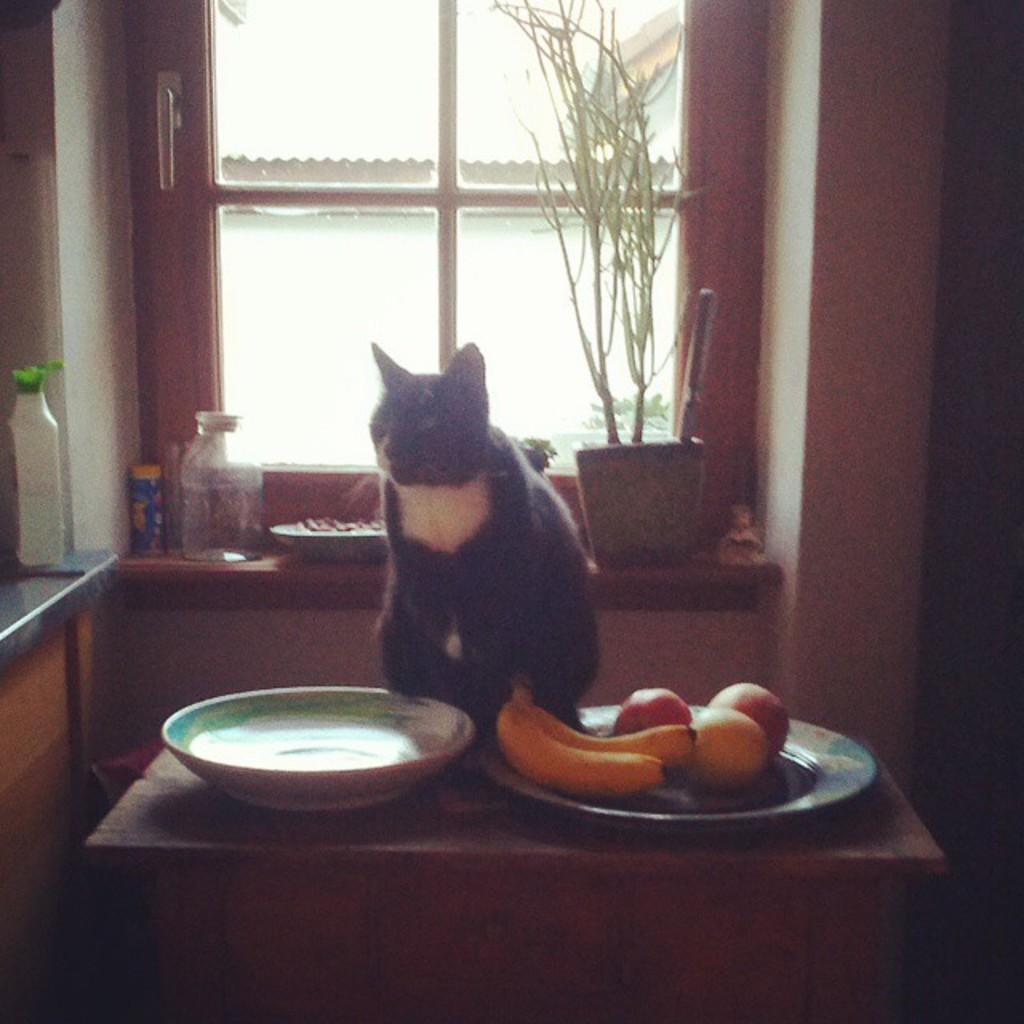Please provide a concise description of this image. There is a cat on the table and the bananas and other fruits on the plate and one bowl seems to be empty. Behind the cat there is a jar, a window and a plant. Left side to the cat there is some dish wash on the table. 